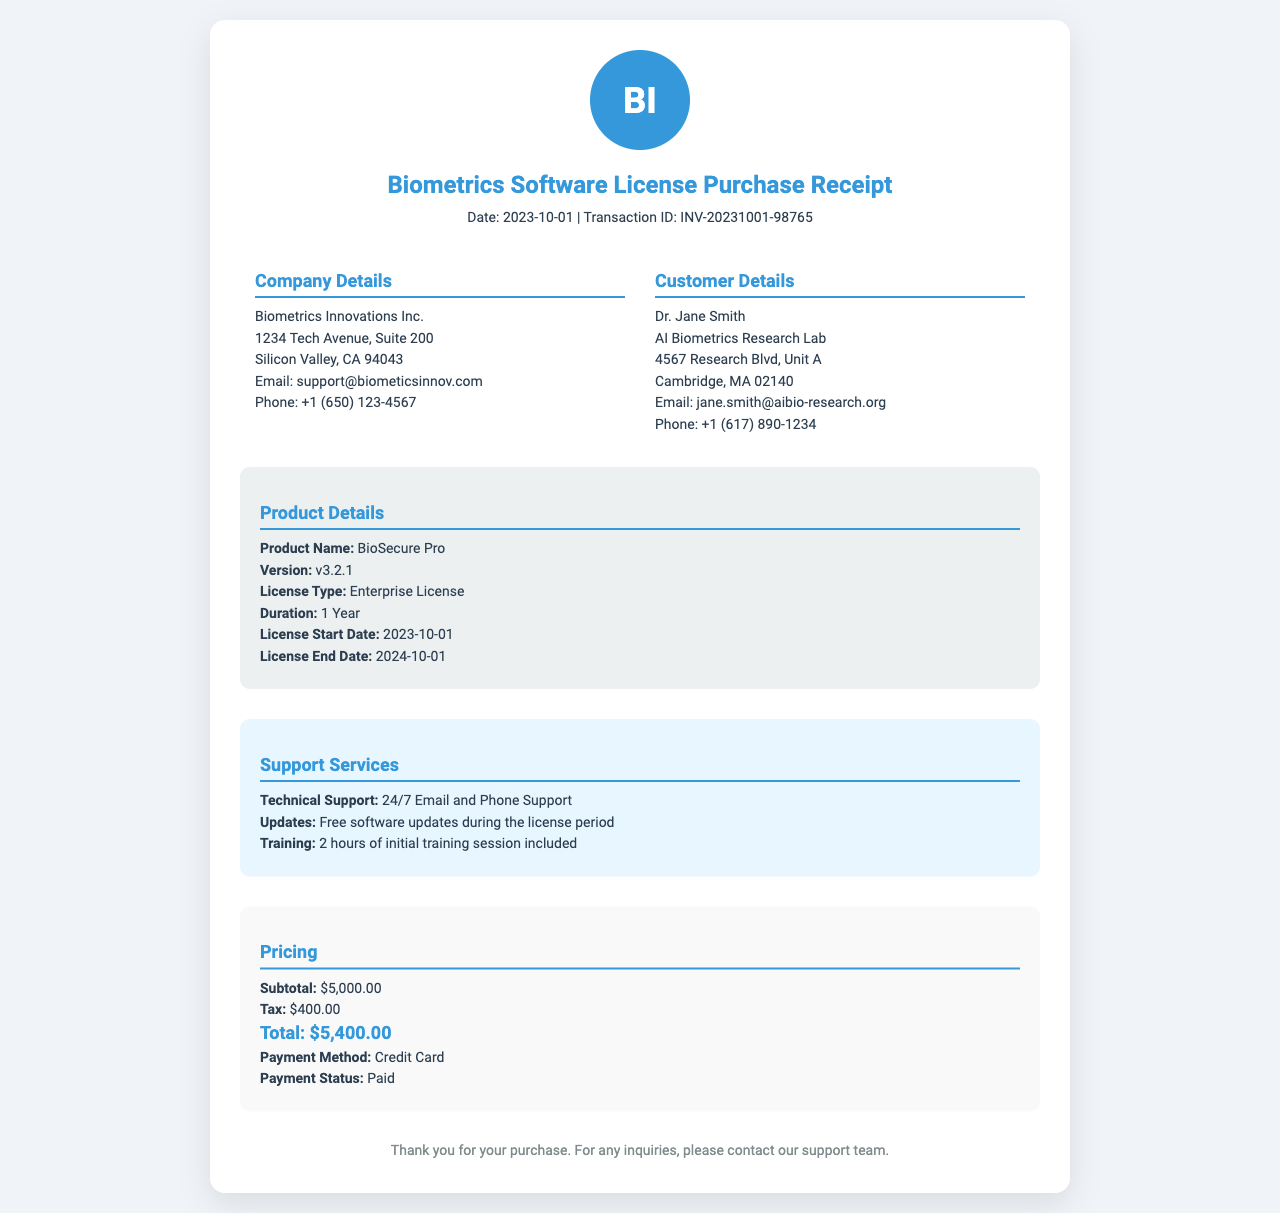What is the product name? The product name is stated clearly in the product details section of the document.
Answer: BioSecure Pro What is the version of the software? The version of the software is mentioned right after the product name in the product details section.
Answer: v3.2.1 What is the duration of the license? The duration can be found in the product details section, and it specifies how long the license is valid.
Answer: 1 Year What is the total amount paid? The total amount is summarized in the pricing section toward the end of the document.
Answer: $5,400.00 What is the payment method? The payment method is specified in the pricing section, detailing how the payment was made.
Answer: Credit Card What type of support is provided? The support services section lists the types of support available during the license period.
Answer: 24/7 Email and Phone Support When does the license start? The start date of the license is given in the product details section, indicating when it begins.
Answer: 2023-10-01 How many hours of training are included? The number of training hours included is specified in the support services section.
Answer: 2 hours What is the transaction ID? The transaction ID is located at the top of the document, indicating the specific purchase.
Answer: INV-20231001-98765 What is the tax amount? The tax amount is listed in the pricing section as part of the financial breakdown.
Answer: $400.00 